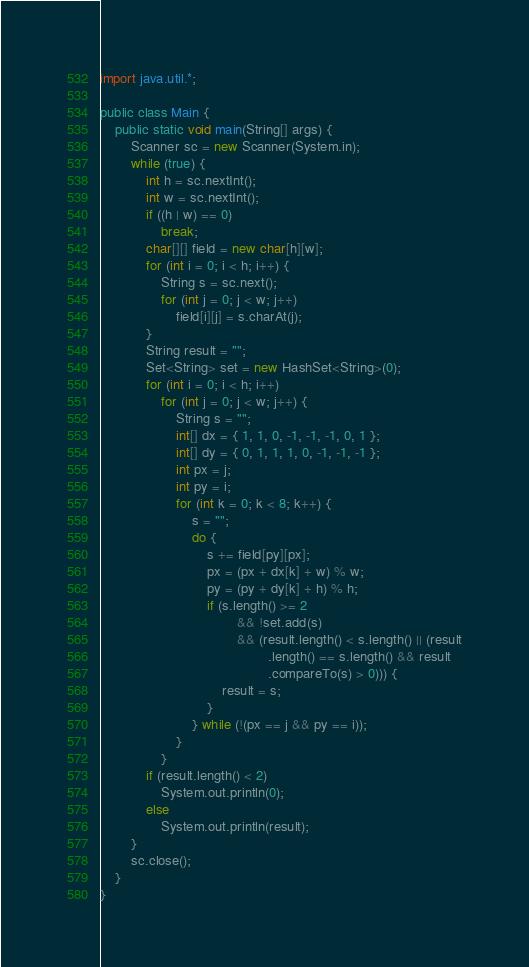<code> <loc_0><loc_0><loc_500><loc_500><_Java_>import java.util.*;

public class Main {
	public static void main(String[] args) {
		Scanner sc = new Scanner(System.in);
		while (true) {
			int h = sc.nextInt();
			int w = sc.nextInt();
			if ((h | w) == 0)
				break;
			char[][] field = new char[h][w];
			for (int i = 0; i < h; i++) {
				String s = sc.next();
				for (int j = 0; j < w; j++)
					field[i][j] = s.charAt(j);
			}
			String result = "";
			Set<String> set = new HashSet<String>(0);
			for (int i = 0; i < h; i++)
				for (int j = 0; j < w; j++) {
					String s = "";
					int[] dx = { 1, 1, 0, -1, -1, -1, 0, 1 };
					int[] dy = { 0, 1, 1, 1, 0, -1, -1, -1 };
					int px = j;
					int py = i;
					for (int k = 0; k < 8; k++) {
						s = "";
						do {
							s += field[py][px];
							px = (px + dx[k] + w) % w;
							py = (py + dy[k] + h) % h;
							if (s.length() >= 2
									&& !set.add(s)
									&& (result.length() < s.length() || (result
											.length() == s.length() && result
											.compareTo(s) > 0))) {
								result = s;
							}
						} while (!(px == j && py == i));
					}
				}
			if (result.length() < 2)
				System.out.println(0);
			else
				System.out.println(result);
		}
		sc.close();
	}
}</code> 